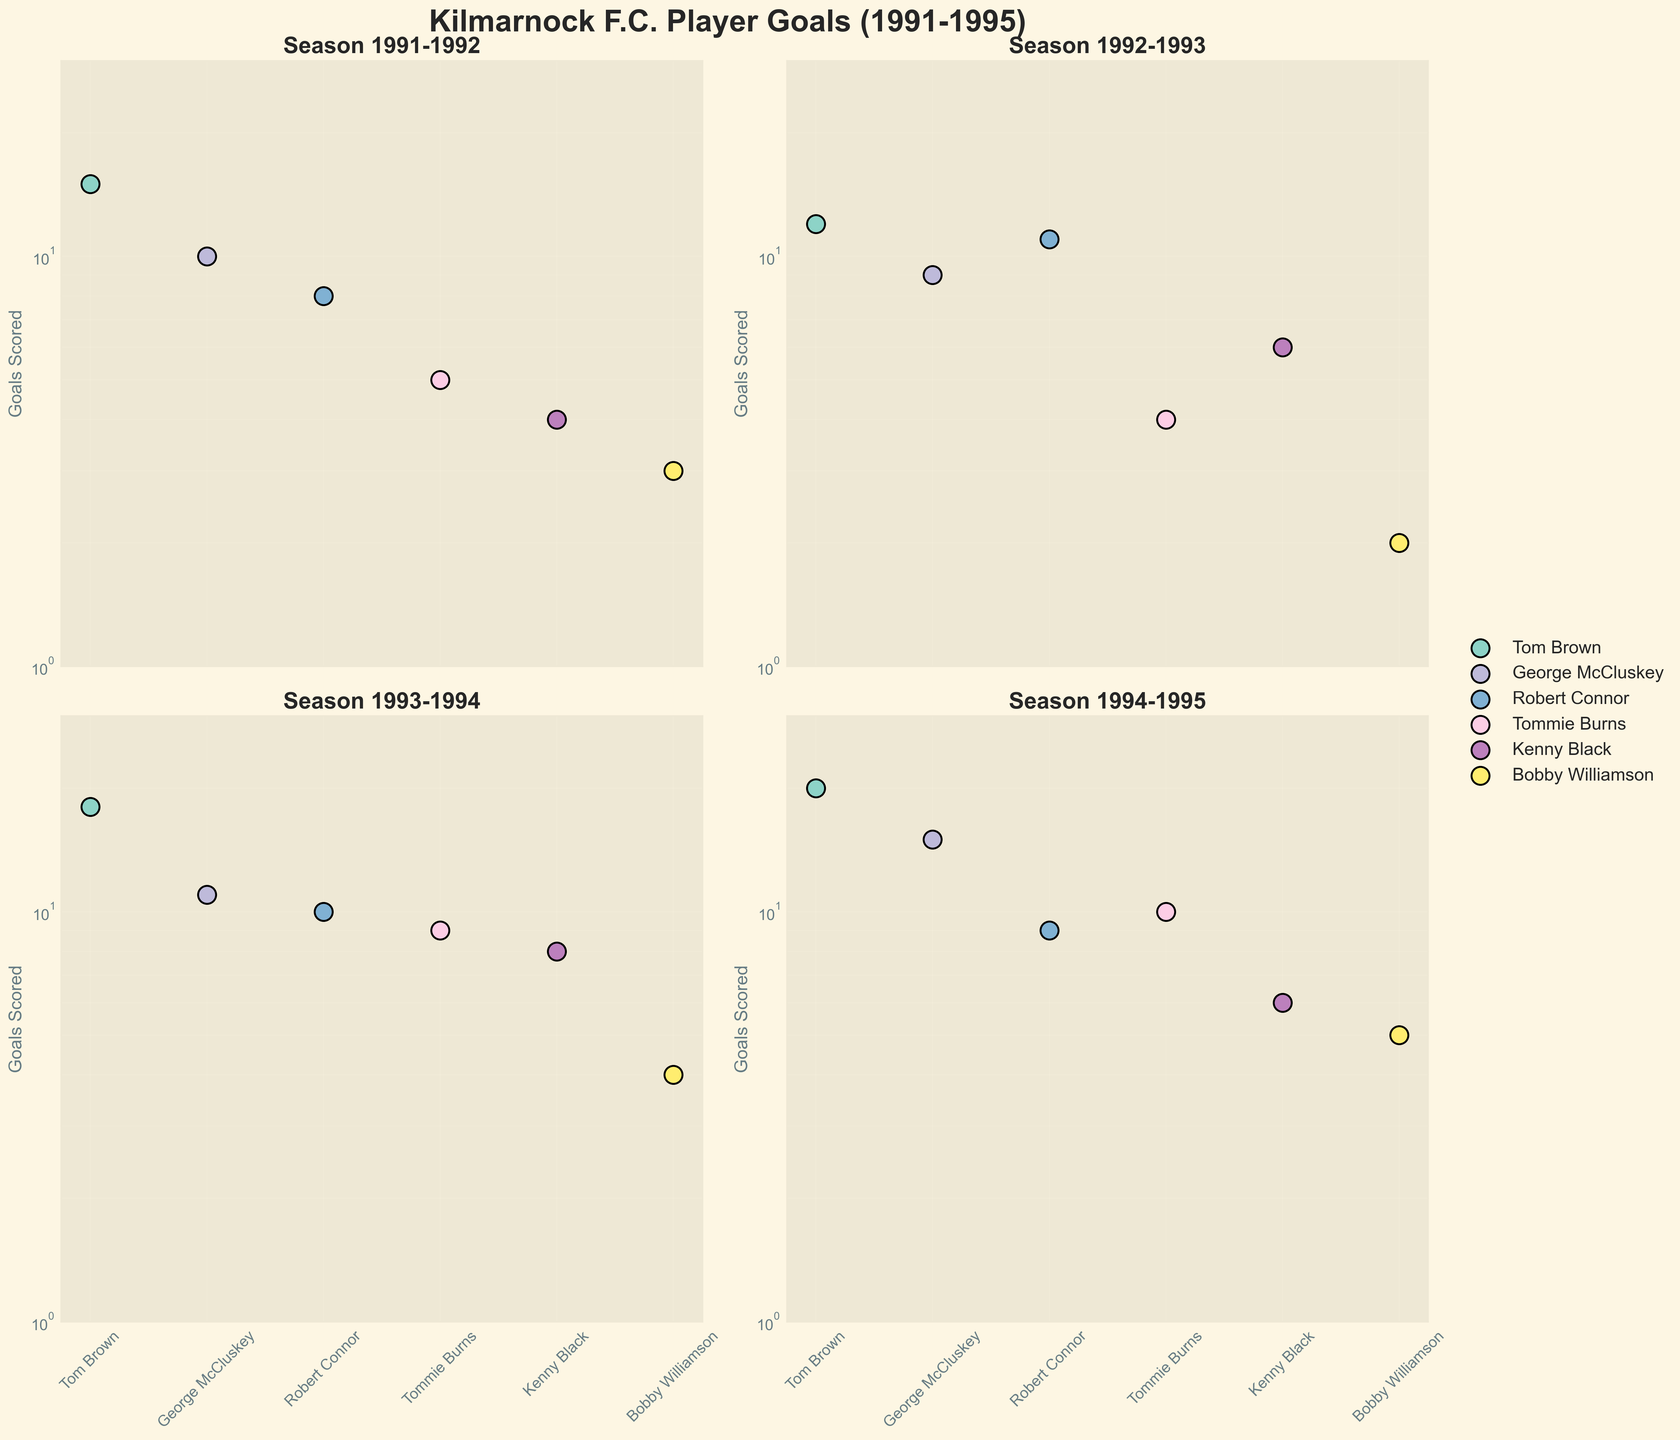What is the title of the entire figure? The title of the figure is prominently displayed at the top.
Answer: "Kilmarnock F.C. Player Goals (1991-1995)" Which season had the highest number of goals scored by Tom Brown? By scanning each subplot for Tom Brown's goal data, you identify the season with the highest value.
Answer: 1994-1995 How many goals did George McCluskey score in the 1993-1994 season? Locate the subplot for the 1993-1994 season and identify the goal value associated with George McCluskey's marker.
Answer: 11 Between the 1991-1992 and 1992-1993 seasons, did Robert Connor's goal tally increase or decrease? Compare Robert Connor's goal values from the 1991-1992 and 1992-1993 subplots to observe any change.
Answer: Increased What is the log-scaled Y-axis range in these subplots? Examine the Y-axis labels on any of the subplots to find the range of values displayed.
Answer: 1 to 30 Which player consistently scored in all the seasons displayed? Look for a player who has a marker in each of the subplots for all seasons.
Answer: Tom Brown In which season did Bobby Williamson score the least number of goals? Compare Bobby Williamson's goal data across all subplots to identify the season with the lowest value.
Answer: 1992-1993 How many players scored goals in the 1994-1995 season? Count the number of unique markers (players) present in the 1994-1995 subplot.
Answer: 6 Did Tommie Burns ever score more than 10 goals in a season? Check each subplot for Tommie Burns' goal values and see if any exceed 10.
Answer: No Comparing the 1991-1992 and 1994-1995 seasons, who had a more significant increase in goals: George McCluskey or Kenny Black? Calculate the increase for both players by subtracting their 1991-1992 goal values from their 1994-1995 values and compare the results. George McCluskey's increase is 15-10=5, and Kenny Black's increase is 6-4=2.
Answer: George McCluskey 